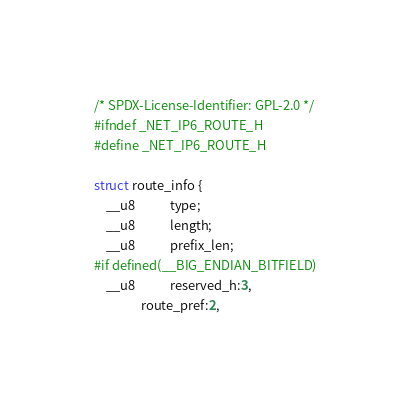Convert code to text. <code><loc_0><loc_0><loc_500><loc_500><_C_>/* SPDX-License-Identifier: GPL-2.0 */
#ifndef _NET_IP6_ROUTE_H
#define _NET_IP6_ROUTE_H

struct route_info {
	__u8			type;
	__u8			length;
	__u8			prefix_len;
#if defined(__BIG_ENDIAN_BITFIELD)
	__u8			reserved_h:3,
				route_pref:2,</code> 